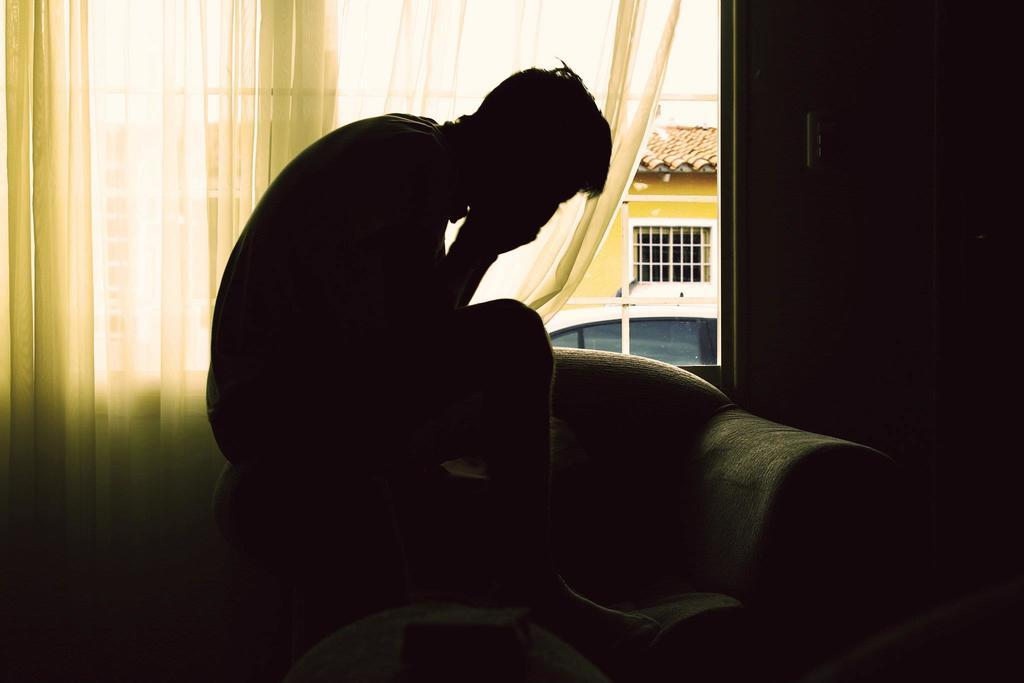What is present in the image that can be used for covering or decorating a window? There is a curtain in the image. What piece of furniture is the man sitting on in the image? The man is sitting on a sofa in the image. What type of plastic material is the minister holding during their journey in the image? There is no minister or journey present in the image, and therefore no such activity or material can be observed. 